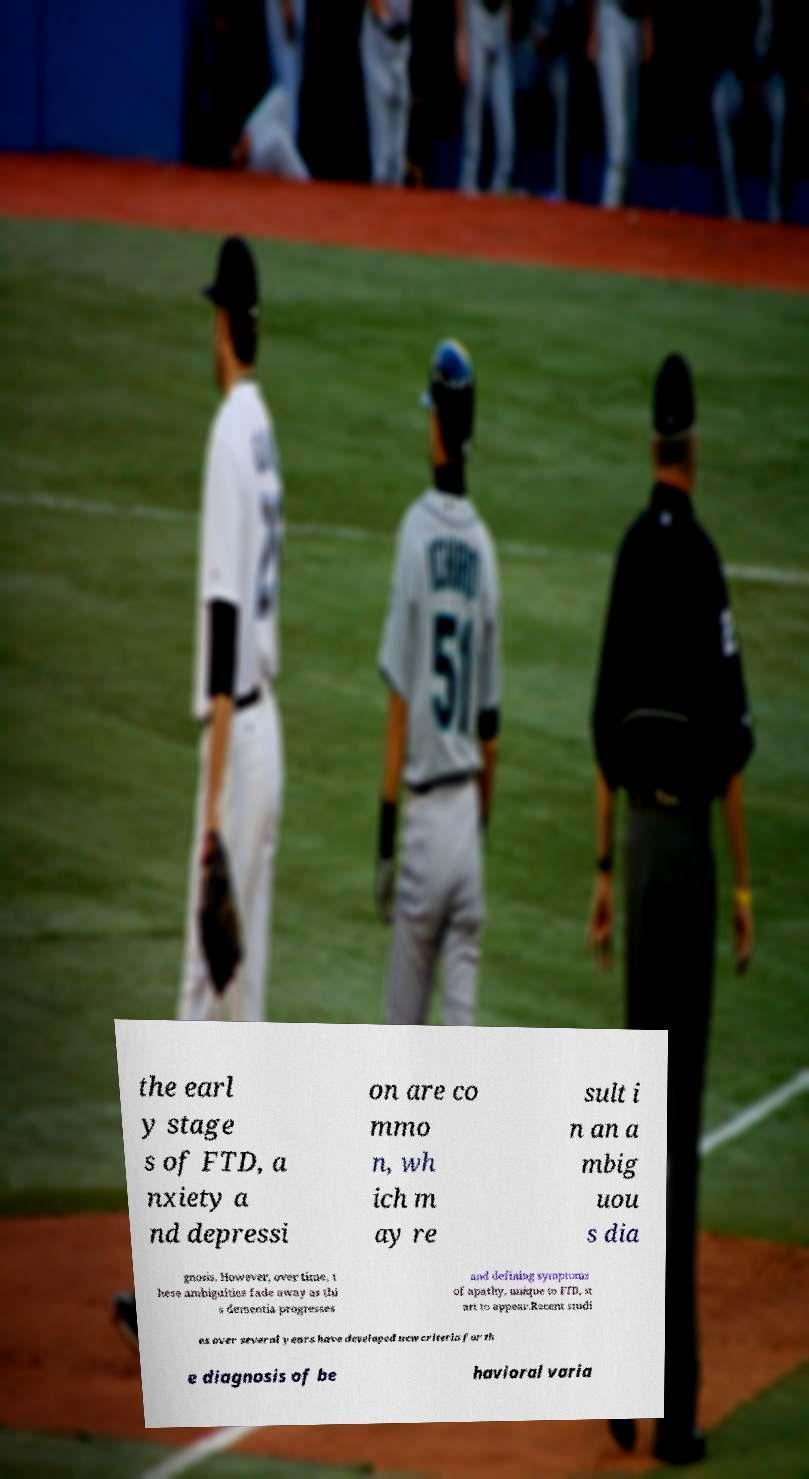For documentation purposes, I need the text within this image transcribed. Could you provide that? the earl y stage s of FTD, a nxiety a nd depressi on are co mmo n, wh ich m ay re sult i n an a mbig uou s dia gnosis. However, over time, t hese ambiguities fade away as thi s dementia progresses and defining symptoms of apathy, unique to FTD, st art to appear.Recent studi es over several years have developed new criteria for th e diagnosis of be havioral varia 